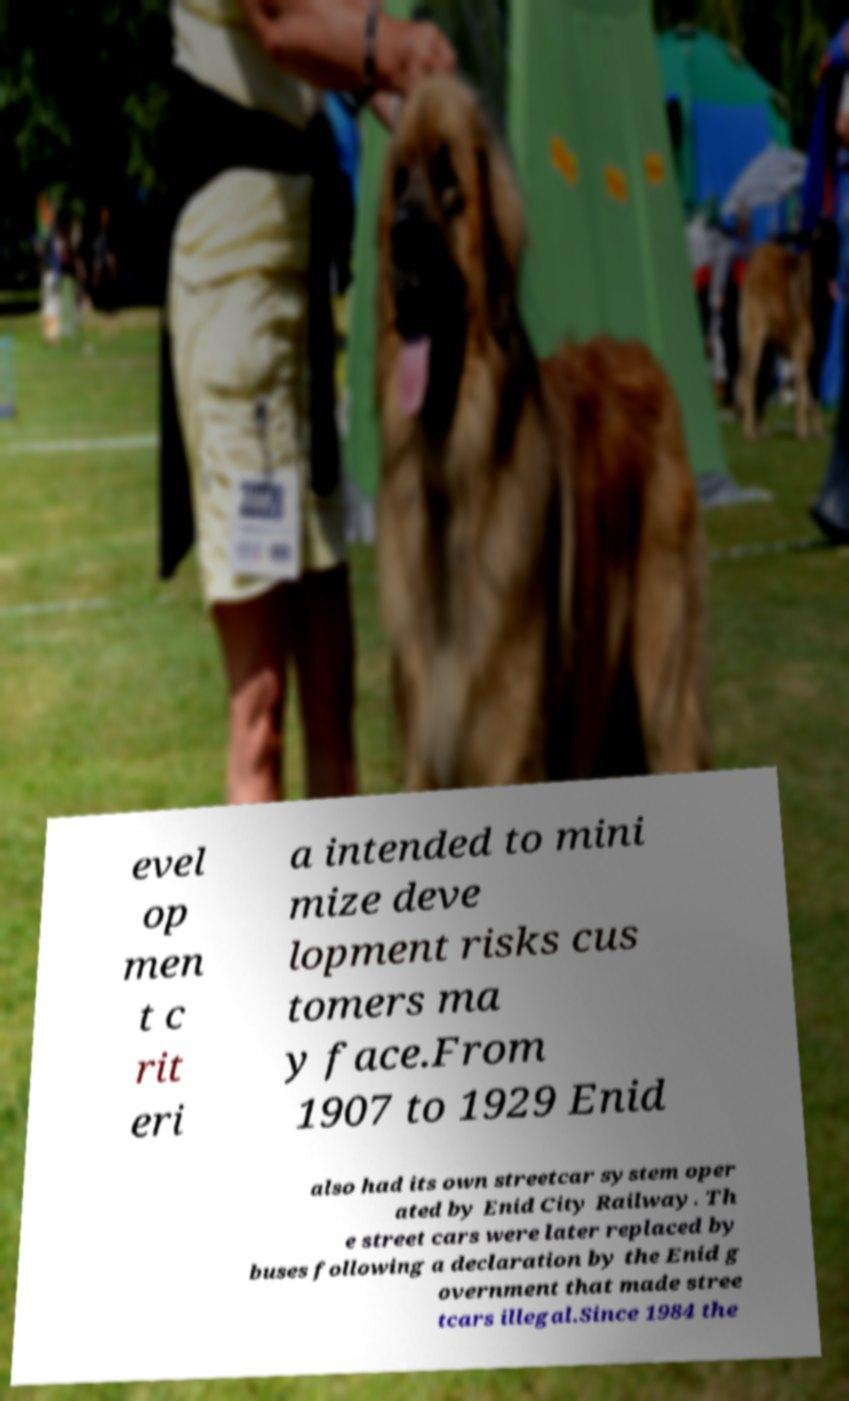Could you extract and type out the text from this image? evel op men t c rit eri a intended to mini mize deve lopment risks cus tomers ma y face.From 1907 to 1929 Enid also had its own streetcar system oper ated by Enid City Railway. Th e street cars were later replaced by buses following a declaration by the Enid g overnment that made stree tcars illegal.Since 1984 the 